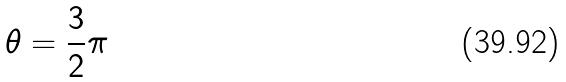<formula> <loc_0><loc_0><loc_500><loc_500>\theta = \frac { 3 } { 2 } \pi</formula> 